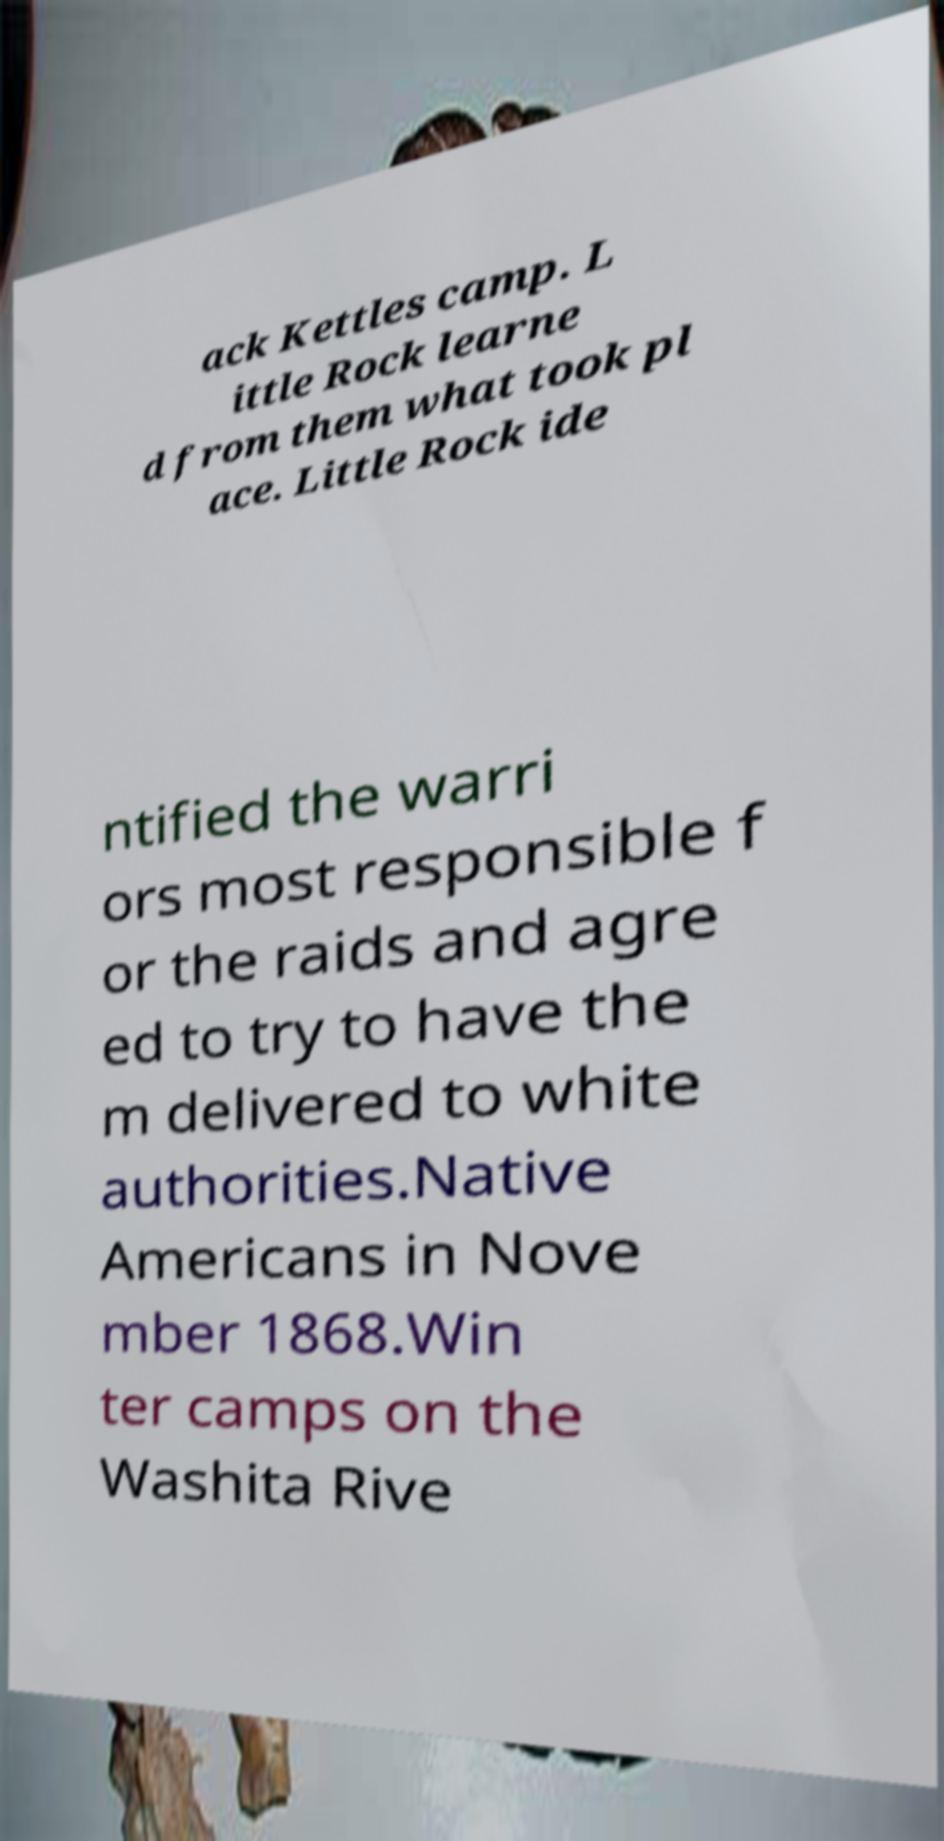There's text embedded in this image that I need extracted. Can you transcribe it verbatim? ack Kettles camp. L ittle Rock learne d from them what took pl ace. Little Rock ide ntified the warri ors most responsible f or the raids and agre ed to try to have the m delivered to white authorities.Native Americans in Nove mber 1868.Win ter camps on the Washita Rive 